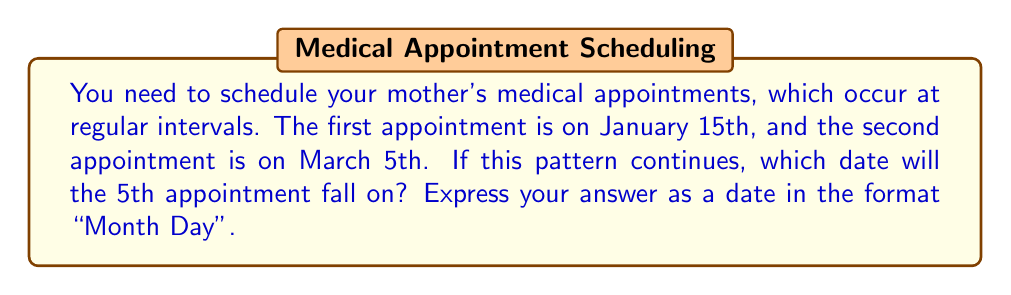Can you solve this math problem? Let's approach this step-by-step using a linear equation:

1) First, we need to determine the interval between appointments:
   January 15th to March 5th = 49 days

2) Let's define our variables:
   Let $x$ be the appointment number
   Let $y$ be the number of days since January 15th

3) We can form a linear equation:
   $y = 49(x-1)$

   Where $x-1$ is used because the first appointment $(x=1)$ is on day 0.

4) For the 5th appointment, $x = 5$:
   $y = 49(5-1) = 49(4) = 196$

5) Now we need to count 196 days from January 15th:
   31 (Jan) + 28 (Feb) + 31 (Mar) + 30 (Apr) + 31 (May) + 30 (Jun) + 15 = 196

6) This brings us to July 30th.
Answer: July 30 